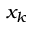Convert formula to latex. <formula><loc_0><loc_0><loc_500><loc_500>x _ { k }</formula> 